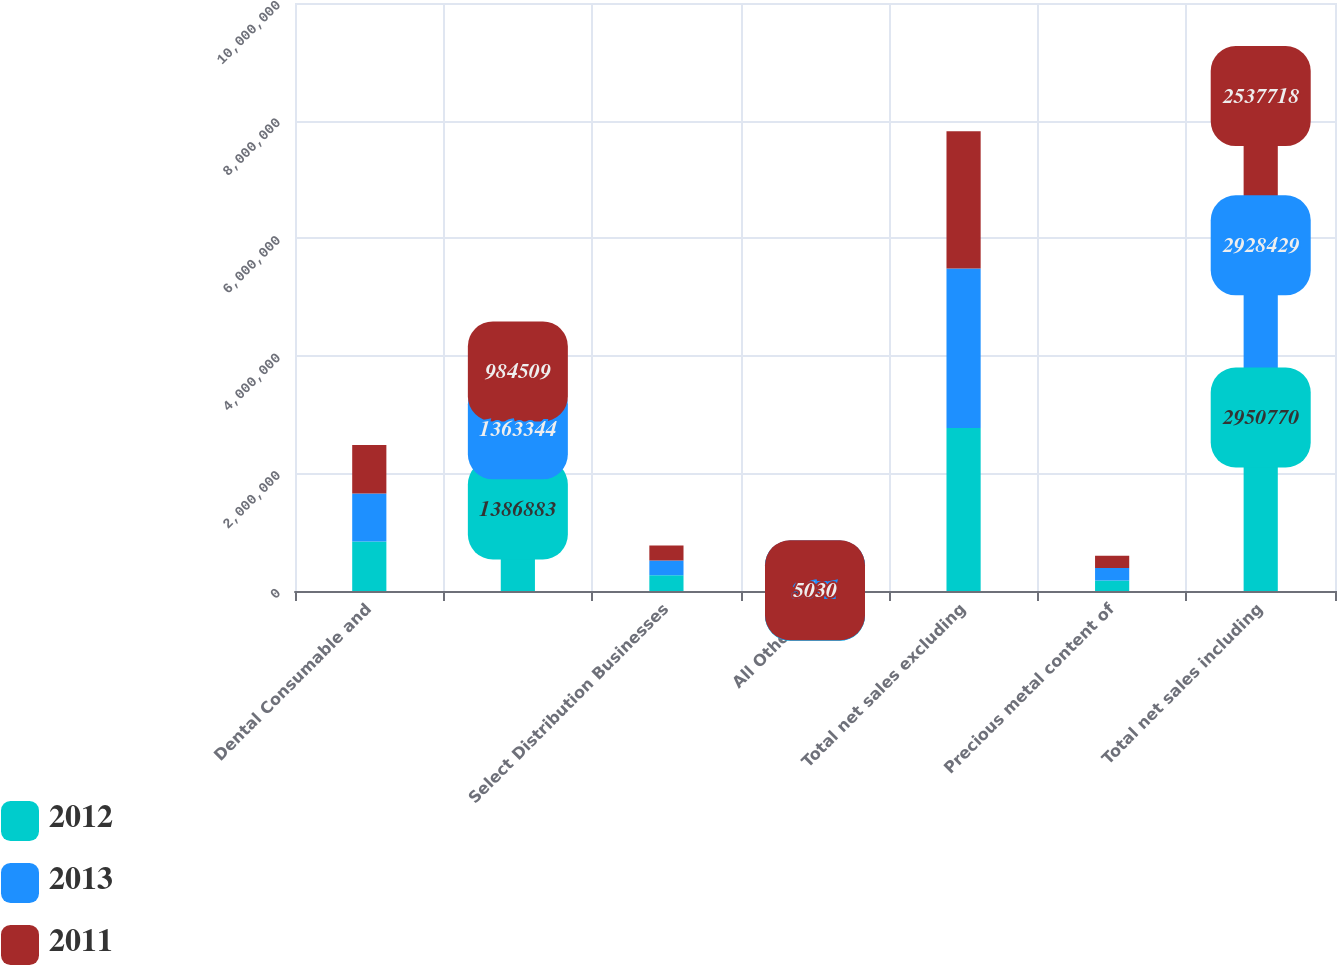<chart> <loc_0><loc_0><loc_500><loc_500><stacked_bar_chart><ecel><fcel>Dental Consumable and<fcel>Unnamed: 2<fcel>Select Distribution Businesses<fcel>All Other (b)<fcel>Total net sales excluding<fcel>Precious metal content of<fcel>Total net sales including<nl><fcel>2012<fcel>842736<fcel>1.38688e+06<fcel>267300<fcel>4185<fcel>2.77173e+06<fcel>179042<fcel>2.95077e+06<nl><fcel>2013<fcel>816281<fcel>1.36334e+06<fcel>252064<fcel>3671<fcel>2.7147e+06<fcel>213731<fcel>2.92843e+06<nl><fcel>2011<fcel>824341<fcel>984509<fcel>252539<fcel>5030<fcel>2.33259e+06<fcel>205131<fcel>2.53772e+06<nl></chart> 